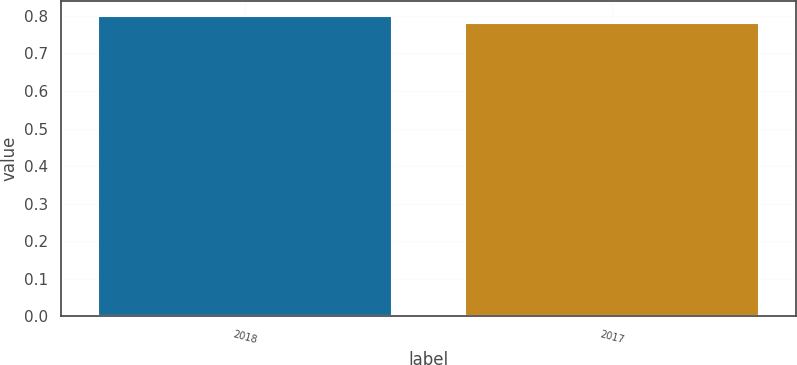<chart> <loc_0><loc_0><loc_500><loc_500><bar_chart><fcel>2018<fcel>2017<nl><fcel>0.8<fcel>0.78<nl></chart> 